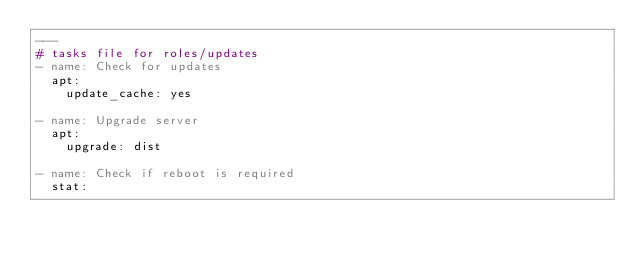Convert code to text. <code><loc_0><loc_0><loc_500><loc_500><_YAML_>---
# tasks file for roles/updates
- name: Check for updates
  apt:
    update_cache: yes

- name: Upgrade server
  apt:
    upgrade: dist

- name: Check if reboot is required
  stat:</code> 